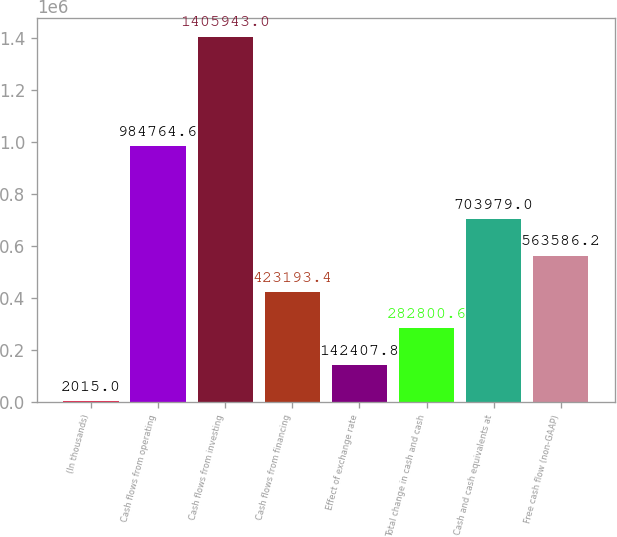Convert chart. <chart><loc_0><loc_0><loc_500><loc_500><bar_chart><fcel>(In thousands)<fcel>Cash flows from operating<fcel>Cash flows from investing<fcel>Cash flows from financing<fcel>Effect of exchange rate<fcel>Total change in cash and cash<fcel>Cash and cash equivalents at<fcel>Free cash flow (non-GAAP)<nl><fcel>2015<fcel>984765<fcel>1.40594e+06<fcel>423193<fcel>142408<fcel>282801<fcel>703979<fcel>563586<nl></chart> 